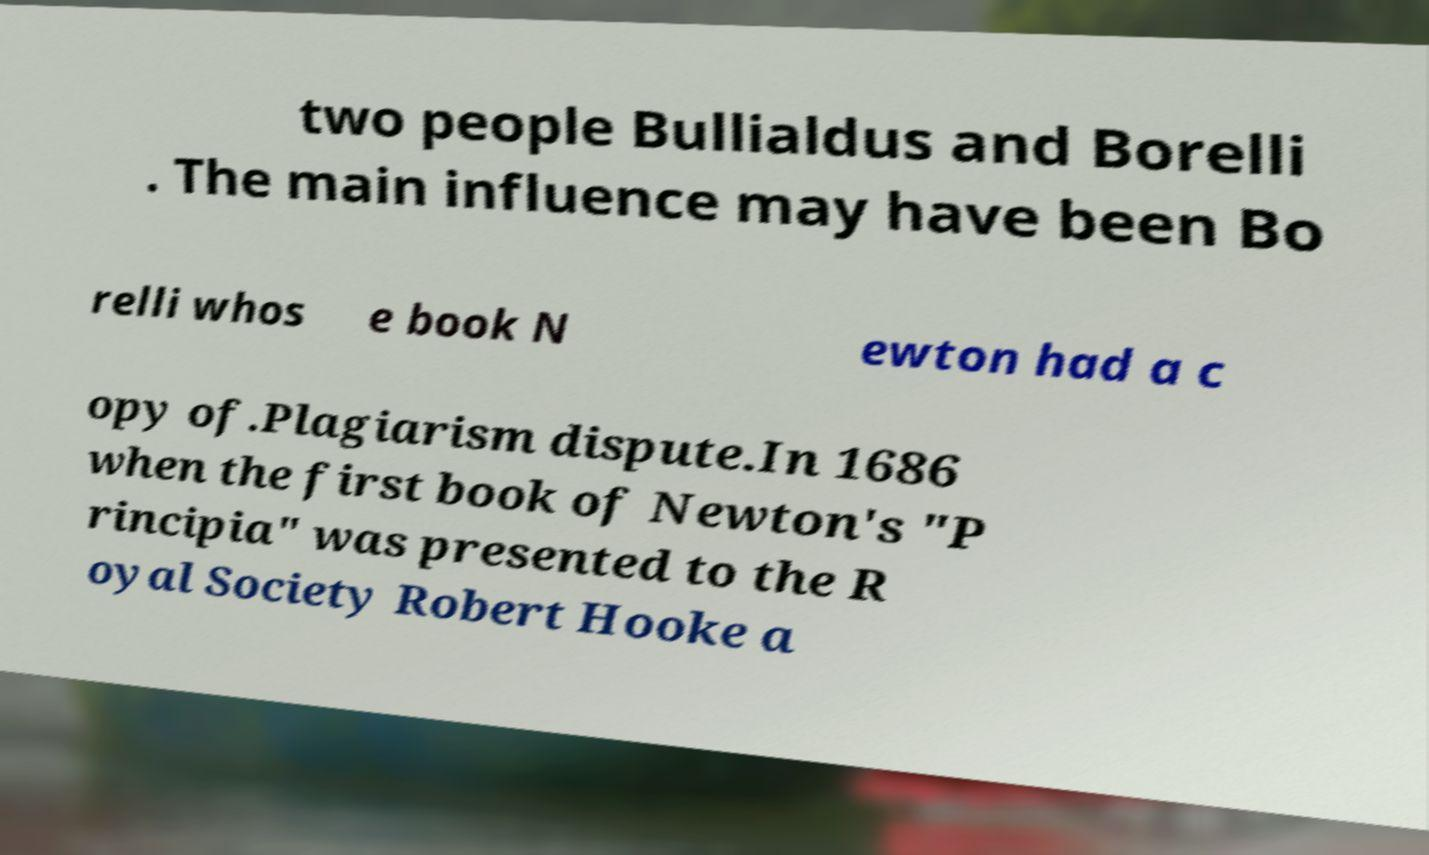Can you read and provide the text displayed in the image?This photo seems to have some interesting text. Can you extract and type it out for me? two people Bullialdus and Borelli . The main influence may have been Bo relli whos e book N ewton had a c opy of.Plagiarism dispute.In 1686 when the first book of Newton's "P rincipia" was presented to the R oyal Society Robert Hooke a 